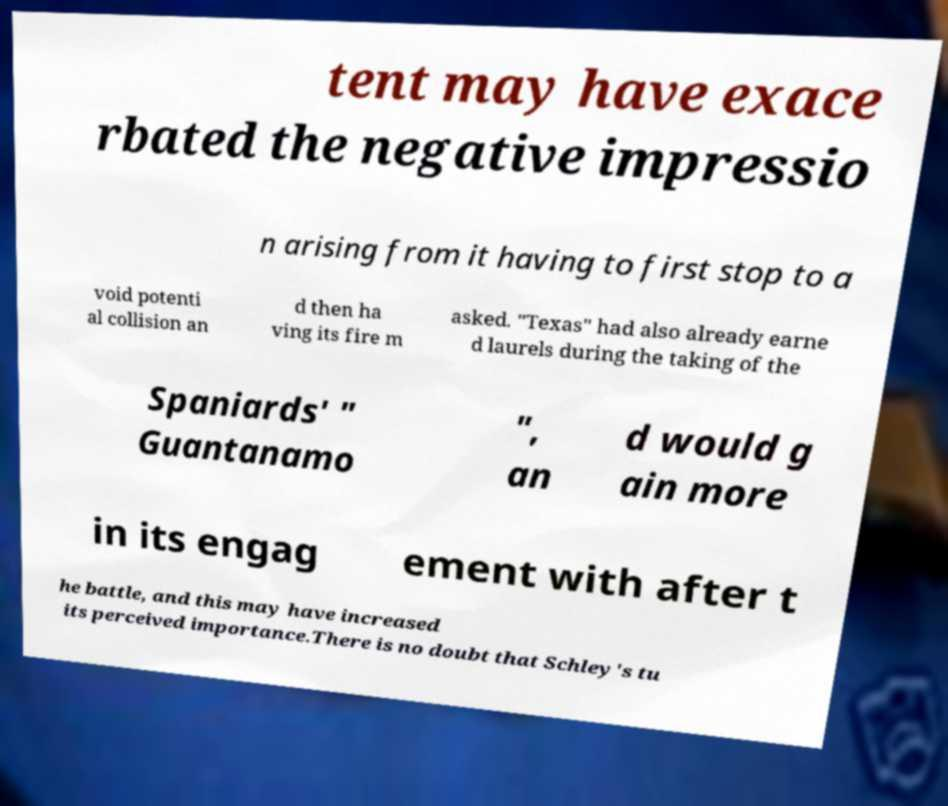For documentation purposes, I need the text within this image transcribed. Could you provide that? tent may have exace rbated the negative impressio n arising from it having to first stop to a void potenti al collision an d then ha ving its fire m asked. "Texas" had also already earne d laurels during the taking of the Spaniards' " Guantanamo ", an d would g ain more in its engag ement with after t he battle, and this may have increased its perceived importance.There is no doubt that Schley's tu 